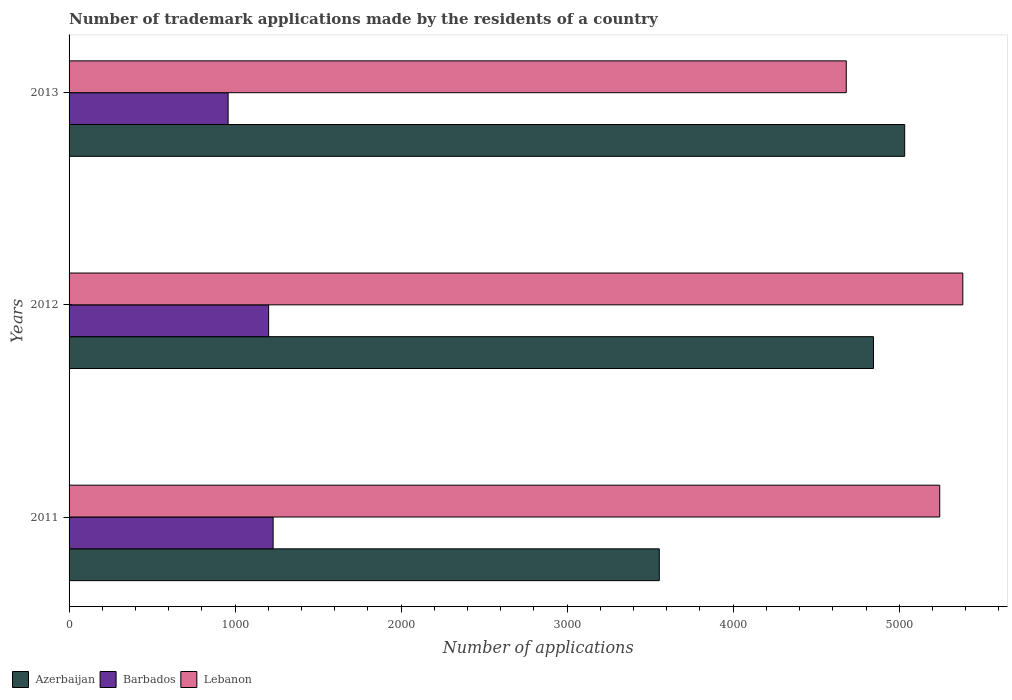How many different coloured bars are there?
Ensure brevity in your answer.  3. What is the label of the 1st group of bars from the top?
Give a very brief answer. 2013. In how many cases, is the number of bars for a given year not equal to the number of legend labels?
Your answer should be compact. 0. What is the number of trademark applications made by the residents in Azerbaijan in 2013?
Offer a terse response. 5033. Across all years, what is the maximum number of trademark applications made by the residents in Azerbaijan?
Give a very brief answer. 5033. Across all years, what is the minimum number of trademark applications made by the residents in Barbados?
Give a very brief answer. 958. In which year was the number of trademark applications made by the residents in Barbados maximum?
Your answer should be very brief. 2011. What is the total number of trademark applications made by the residents in Azerbaijan in the graph?
Provide a succinct answer. 1.34e+04. What is the difference between the number of trademark applications made by the residents in Barbados in 2012 and that in 2013?
Your answer should be very brief. 244. What is the difference between the number of trademark applications made by the residents in Azerbaijan in 2013 and the number of trademark applications made by the residents in Barbados in 2012?
Keep it short and to the point. 3831. What is the average number of trademark applications made by the residents in Azerbaijan per year?
Make the answer very short. 4477.67. In the year 2013, what is the difference between the number of trademark applications made by the residents in Azerbaijan and number of trademark applications made by the residents in Barbados?
Your answer should be very brief. 4075. In how many years, is the number of trademark applications made by the residents in Lebanon greater than 4800 ?
Your answer should be compact. 2. What is the ratio of the number of trademark applications made by the residents in Lebanon in 2011 to that in 2013?
Give a very brief answer. 1.12. Is the difference between the number of trademark applications made by the residents in Azerbaijan in 2011 and 2012 greater than the difference between the number of trademark applications made by the residents in Barbados in 2011 and 2012?
Ensure brevity in your answer.  No. What is the difference between the highest and the lowest number of trademark applications made by the residents in Azerbaijan?
Your response must be concise. 1478. In how many years, is the number of trademark applications made by the residents in Azerbaijan greater than the average number of trademark applications made by the residents in Azerbaijan taken over all years?
Give a very brief answer. 2. Is the sum of the number of trademark applications made by the residents in Azerbaijan in 2011 and 2013 greater than the maximum number of trademark applications made by the residents in Lebanon across all years?
Offer a terse response. Yes. What does the 3rd bar from the top in 2012 represents?
Ensure brevity in your answer.  Azerbaijan. What does the 2nd bar from the bottom in 2013 represents?
Give a very brief answer. Barbados. Are all the bars in the graph horizontal?
Your response must be concise. Yes. What is the difference between two consecutive major ticks on the X-axis?
Offer a very short reply. 1000. Are the values on the major ticks of X-axis written in scientific E-notation?
Make the answer very short. No. Does the graph contain any zero values?
Provide a short and direct response. No. Does the graph contain grids?
Keep it short and to the point. No. Where does the legend appear in the graph?
Offer a terse response. Bottom left. What is the title of the graph?
Keep it short and to the point. Number of trademark applications made by the residents of a country. Does "Ukraine" appear as one of the legend labels in the graph?
Provide a succinct answer. No. What is the label or title of the X-axis?
Make the answer very short. Number of applications. What is the Number of applications of Azerbaijan in 2011?
Your response must be concise. 3555. What is the Number of applications of Barbados in 2011?
Provide a short and direct response. 1229. What is the Number of applications of Lebanon in 2011?
Provide a short and direct response. 5244. What is the Number of applications in Azerbaijan in 2012?
Your answer should be very brief. 4845. What is the Number of applications of Barbados in 2012?
Your answer should be very brief. 1202. What is the Number of applications of Lebanon in 2012?
Keep it short and to the point. 5383. What is the Number of applications in Azerbaijan in 2013?
Provide a short and direct response. 5033. What is the Number of applications in Barbados in 2013?
Your answer should be very brief. 958. What is the Number of applications of Lebanon in 2013?
Offer a terse response. 4681. Across all years, what is the maximum Number of applications in Azerbaijan?
Offer a very short reply. 5033. Across all years, what is the maximum Number of applications in Barbados?
Ensure brevity in your answer.  1229. Across all years, what is the maximum Number of applications in Lebanon?
Your response must be concise. 5383. Across all years, what is the minimum Number of applications of Azerbaijan?
Your answer should be compact. 3555. Across all years, what is the minimum Number of applications in Barbados?
Keep it short and to the point. 958. Across all years, what is the minimum Number of applications of Lebanon?
Offer a very short reply. 4681. What is the total Number of applications in Azerbaijan in the graph?
Offer a terse response. 1.34e+04. What is the total Number of applications of Barbados in the graph?
Provide a short and direct response. 3389. What is the total Number of applications in Lebanon in the graph?
Your response must be concise. 1.53e+04. What is the difference between the Number of applications of Azerbaijan in 2011 and that in 2012?
Make the answer very short. -1290. What is the difference between the Number of applications of Barbados in 2011 and that in 2012?
Provide a short and direct response. 27. What is the difference between the Number of applications in Lebanon in 2011 and that in 2012?
Your answer should be compact. -139. What is the difference between the Number of applications of Azerbaijan in 2011 and that in 2013?
Offer a terse response. -1478. What is the difference between the Number of applications of Barbados in 2011 and that in 2013?
Offer a very short reply. 271. What is the difference between the Number of applications of Lebanon in 2011 and that in 2013?
Make the answer very short. 563. What is the difference between the Number of applications of Azerbaijan in 2012 and that in 2013?
Your answer should be compact. -188. What is the difference between the Number of applications in Barbados in 2012 and that in 2013?
Offer a very short reply. 244. What is the difference between the Number of applications in Lebanon in 2012 and that in 2013?
Your answer should be compact. 702. What is the difference between the Number of applications of Azerbaijan in 2011 and the Number of applications of Barbados in 2012?
Offer a terse response. 2353. What is the difference between the Number of applications of Azerbaijan in 2011 and the Number of applications of Lebanon in 2012?
Your answer should be very brief. -1828. What is the difference between the Number of applications of Barbados in 2011 and the Number of applications of Lebanon in 2012?
Offer a terse response. -4154. What is the difference between the Number of applications in Azerbaijan in 2011 and the Number of applications in Barbados in 2013?
Keep it short and to the point. 2597. What is the difference between the Number of applications in Azerbaijan in 2011 and the Number of applications in Lebanon in 2013?
Provide a short and direct response. -1126. What is the difference between the Number of applications of Barbados in 2011 and the Number of applications of Lebanon in 2013?
Your answer should be very brief. -3452. What is the difference between the Number of applications of Azerbaijan in 2012 and the Number of applications of Barbados in 2013?
Offer a terse response. 3887. What is the difference between the Number of applications of Azerbaijan in 2012 and the Number of applications of Lebanon in 2013?
Offer a very short reply. 164. What is the difference between the Number of applications of Barbados in 2012 and the Number of applications of Lebanon in 2013?
Provide a succinct answer. -3479. What is the average Number of applications of Azerbaijan per year?
Keep it short and to the point. 4477.67. What is the average Number of applications of Barbados per year?
Ensure brevity in your answer.  1129.67. What is the average Number of applications in Lebanon per year?
Ensure brevity in your answer.  5102.67. In the year 2011, what is the difference between the Number of applications in Azerbaijan and Number of applications in Barbados?
Make the answer very short. 2326. In the year 2011, what is the difference between the Number of applications in Azerbaijan and Number of applications in Lebanon?
Your response must be concise. -1689. In the year 2011, what is the difference between the Number of applications in Barbados and Number of applications in Lebanon?
Provide a short and direct response. -4015. In the year 2012, what is the difference between the Number of applications in Azerbaijan and Number of applications in Barbados?
Offer a terse response. 3643. In the year 2012, what is the difference between the Number of applications in Azerbaijan and Number of applications in Lebanon?
Provide a short and direct response. -538. In the year 2012, what is the difference between the Number of applications in Barbados and Number of applications in Lebanon?
Provide a short and direct response. -4181. In the year 2013, what is the difference between the Number of applications of Azerbaijan and Number of applications of Barbados?
Provide a short and direct response. 4075. In the year 2013, what is the difference between the Number of applications of Azerbaijan and Number of applications of Lebanon?
Give a very brief answer. 352. In the year 2013, what is the difference between the Number of applications of Barbados and Number of applications of Lebanon?
Your answer should be very brief. -3723. What is the ratio of the Number of applications in Azerbaijan in 2011 to that in 2012?
Your answer should be very brief. 0.73. What is the ratio of the Number of applications in Barbados in 2011 to that in 2012?
Offer a terse response. 1.02. What is the ratio of the Number of applications in Lebanon in 2011 to that in 2012?
Your response must be concise. 0.97. What is the ratio of the Number of applications of Azerbaijan in 2011 to that in 2013?
Your answer should be very brief. 0.71. What is the ratio of the Number of applications in Barbados in 2011 to that in 2013?
Provide a short and direct response. 1.28. What is the ratio of the Number of applications in Lebanon in 2011 to that in 2013?
Keep it short and to the point. 1.12. What is the ratio of the Number of applications in Azerbaijan in 2012 to that in 2013?
Ensure brevity in your answer.  0.96. What is the ratio of the Number of applications of Barbados in 2012 to that in 2013?
Keep it short and to the point. 1.25. What is the ratio of the Number of applications of Lebanon in 2012 to that in 2013?
Make the answer very short. 1.15. What is the difference between the highest and the second highest Number of applications of Azerbaijan?
Provide a short and direct response. 188. What is the difference between the highest and the second highest Number of applications of Lebanon?
Keep it short and to the point. 139. What is the difference between the highest and the lowest Number of applications in Azerbaijan?
Provide a succinct answer. 1478. What is the difference between the highest and the lowest Number of applications of Barbados?
Offer a terse response. 271. What is the difference between the highest and the lowest Number of applications in Lebanon?
Provide a succinct answer. 702. 